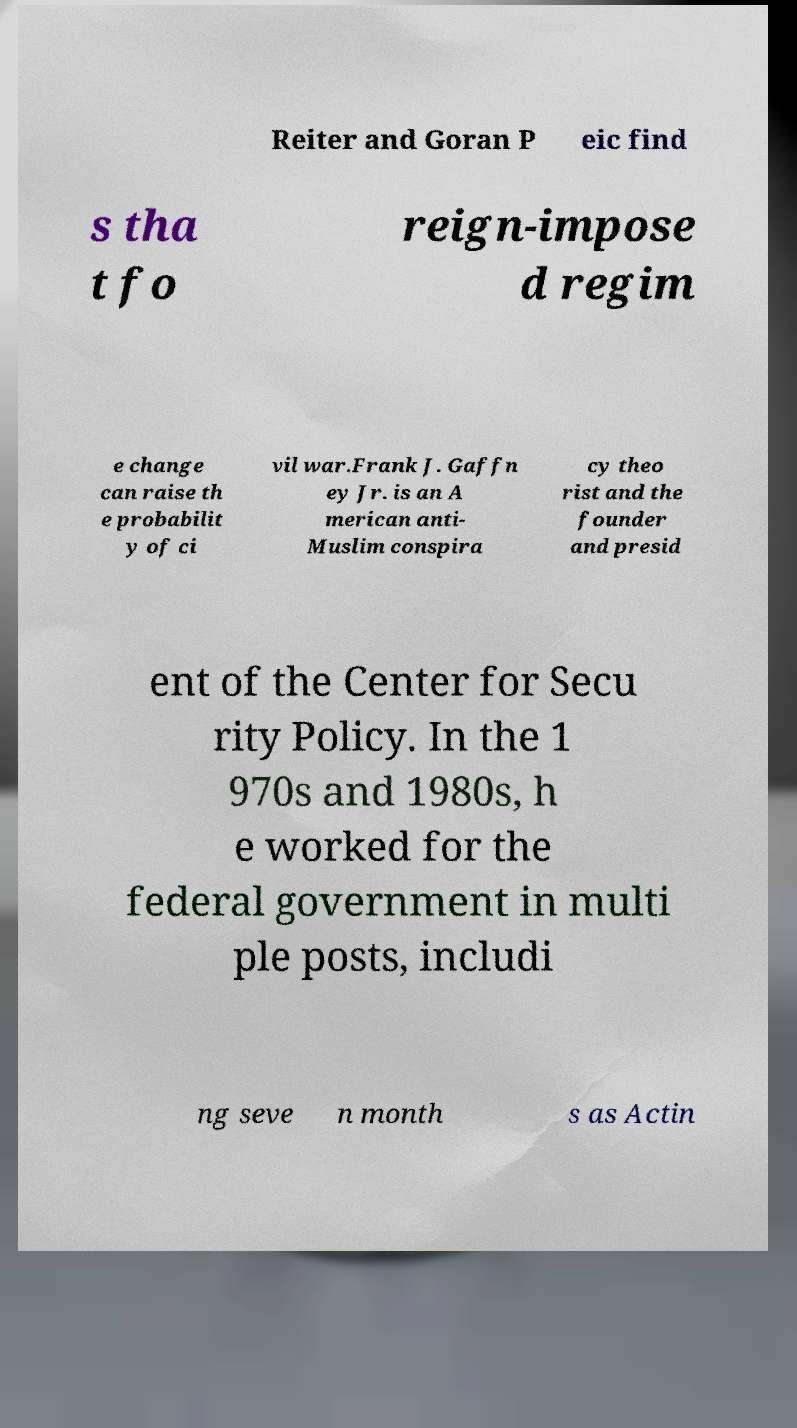Can you read and provide the text displayed in the image?This photo seems to have some interesting text. Can you extract and type it out for me? Reiter and Goran P eic find s tha t fo reign-impose d regim e change can raise th e probabilit y of ci vil war.Frank J. Gaffn ey Jr. is an A merican anti- Muslim conspira cy theo rist and the founder and presid ent of the Center for Secu rity Policy. In the 1 970s and 1980s, h e worked for the federal government in multi ple posts, includi ng seve n month s as Actin 